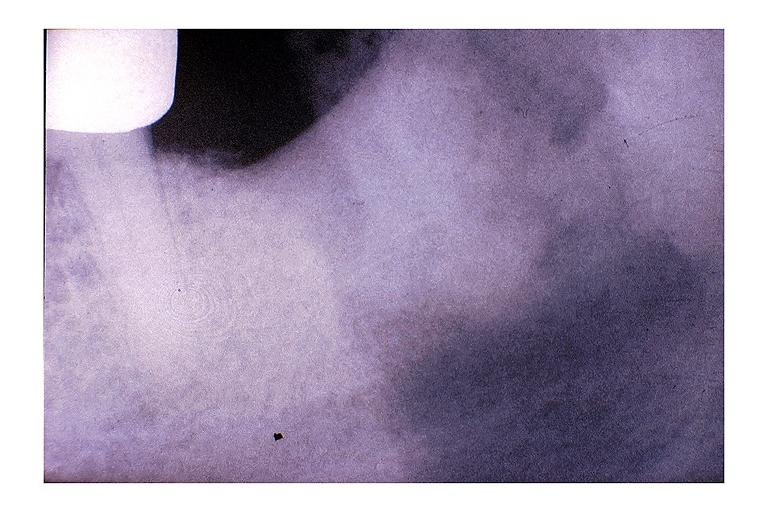s heart present?
Answer the question using a single word or phrase. No 